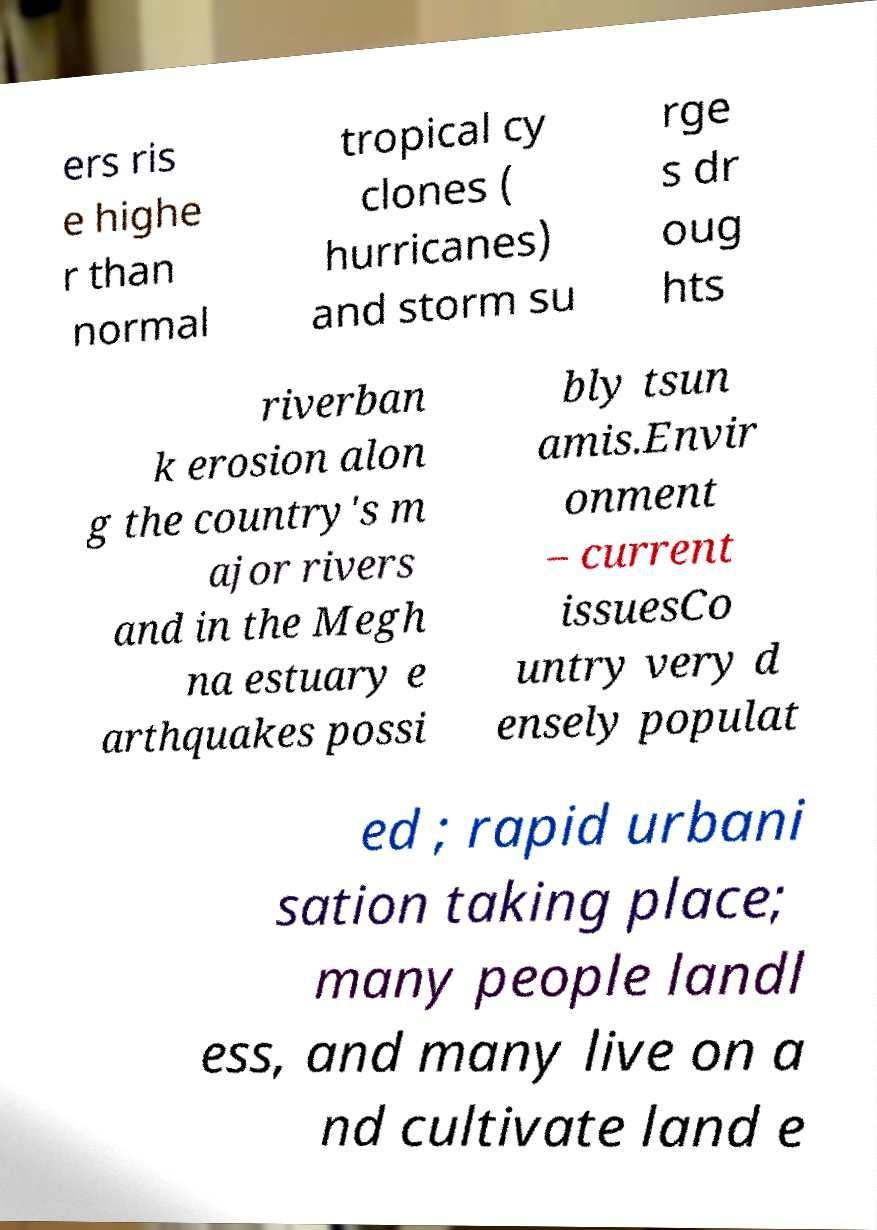Please identify and transcribe the text found in this image. ers ris e highe r than normal tropical cy clones ( hurricanes) and storm su rge s dr oug hts riverban k erosion alon g the country's m ajor rivers and in the Megh na estuary e arthquakes possi bly tsun amis.Envir onment – current issuesCo untry very d ensely populat ed ; rapid urbani sation taking place; many people landl ess, and many live on a nd cultivate land e 